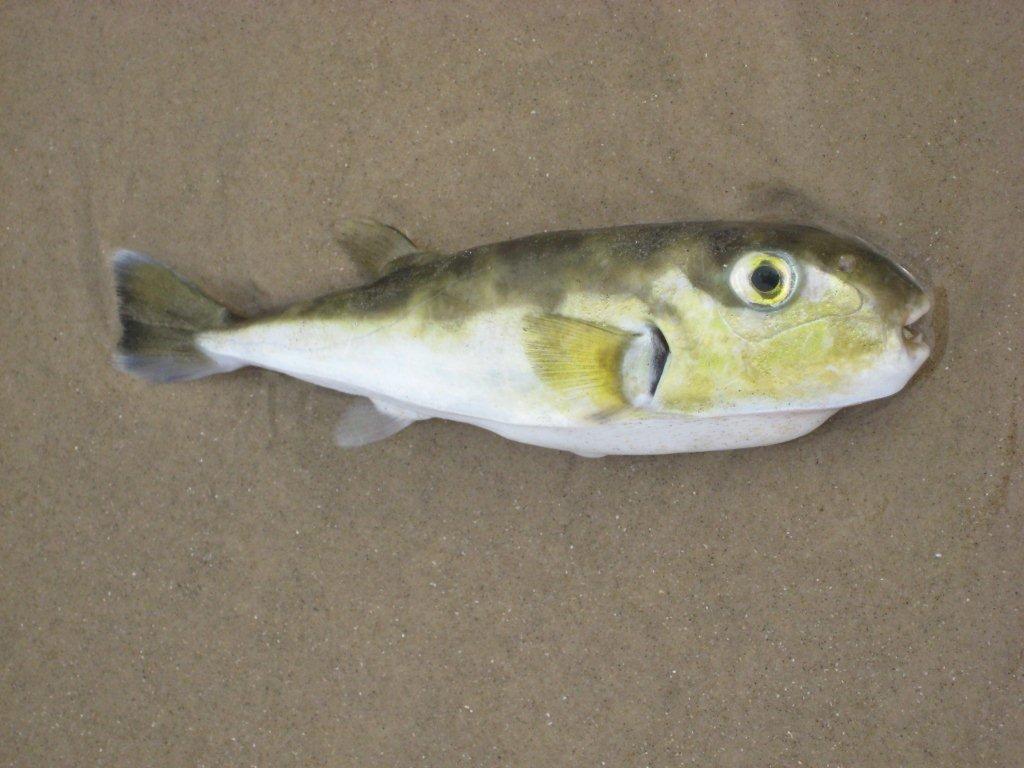In one or two sentences, can you explain what this image depicts? In this image I can see a colorful fish. 